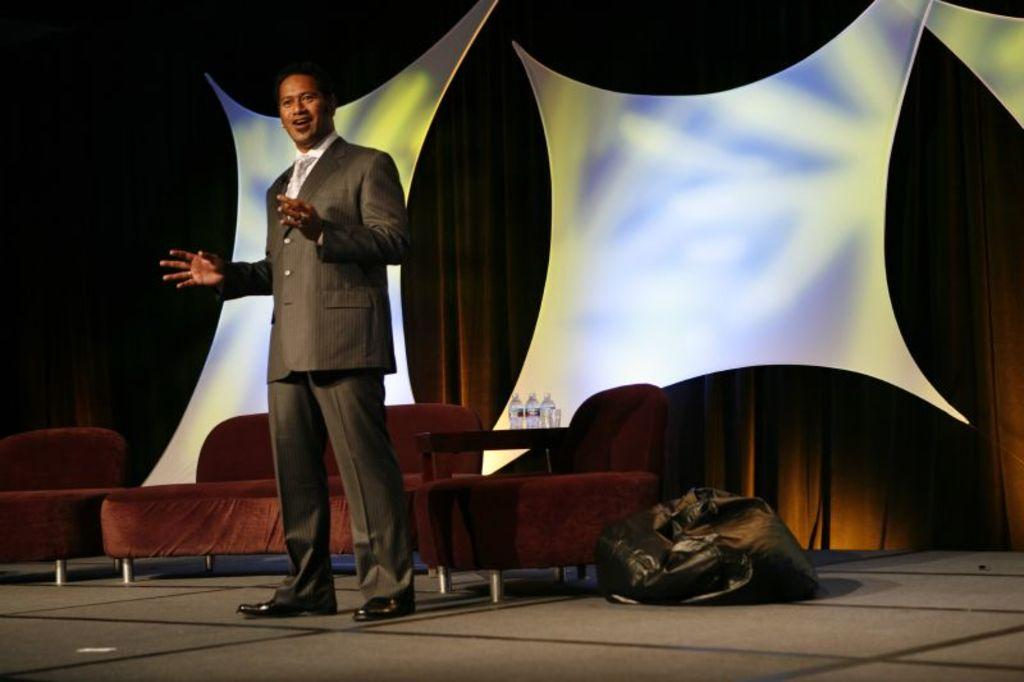What is the main subject in the foreground of the image? There is a man standing in the foreground of the image. What type of furniture can be seen in the image? There are sofas in the image. What objects are present that might contain liquid? There are bottles in the image. What can be seen in the background of the image? There is a stage wall in the background of the image. Can you tell me how many frogs are sitting on the sofas in the image? There are no frogs present in the image; only a man, sofas, bottles, and a stage wall can be seen. What is the title of the book the man is holding in the image? There is no book visible in the image, so it is not possible to determine the title. 